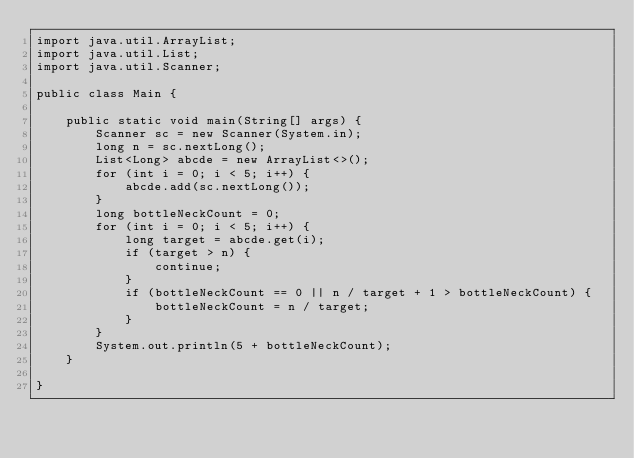<code> <loc_0><loc_0><loc_500><loc_500><_Java_>import java.util.ArrayList;
import java.util.List;
import java.util.Scanner;

public class Main {

    public static void main(String[] args) {
        Scanner sc = new Scanner(System.in);
        long n = sc.nextLong();
        List<Long> abcde = new ArrayList<>();
        for (int i = 0; i < 5; i++) {
            abcde.add(sc.nextLong());
        }
        long bottleNeckCount = 0;
        for (int i = 0; i < 5; i++) {
            long target = abcde.get(i);
            if (target > n) {
                continue;
            }
            if (bottleNeckCount == 0 || n / target + 1 > bottleNeckCount) {
                bottleNeckCount = n / target;
            }
        }
        System.out.println(5 + bottleNeckCount);
    }

}
</code> 